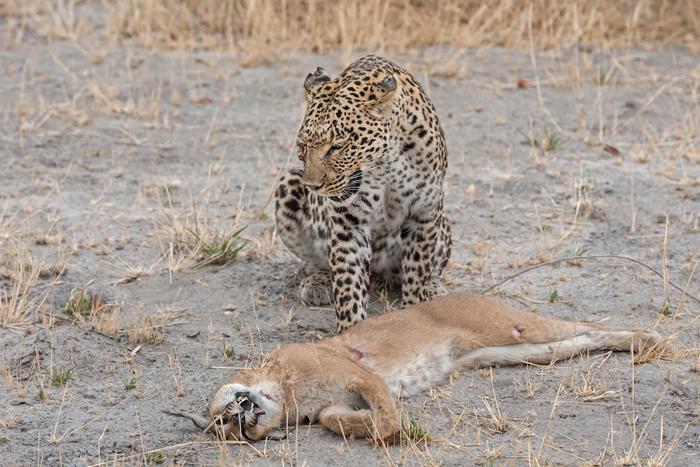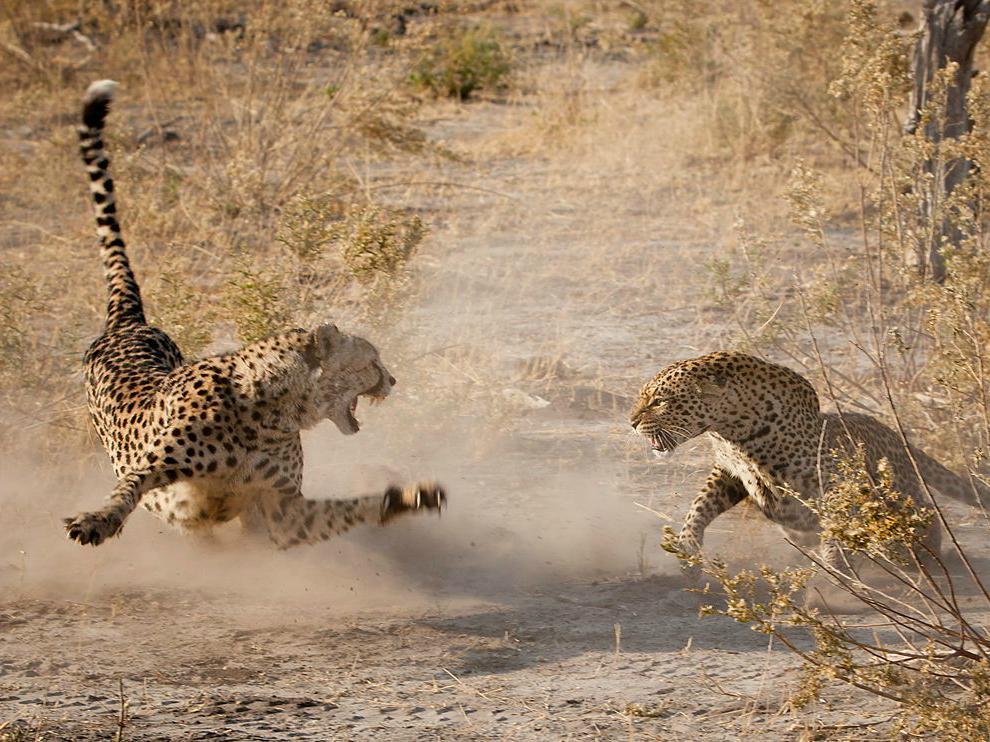The first image is the image on the left, the second image is the image on the right. For the images shown, is this caption "There is a cheetah with a dead caracal in one image, and two cheetahs in the other image." true? Answer yes or no. Yes. 